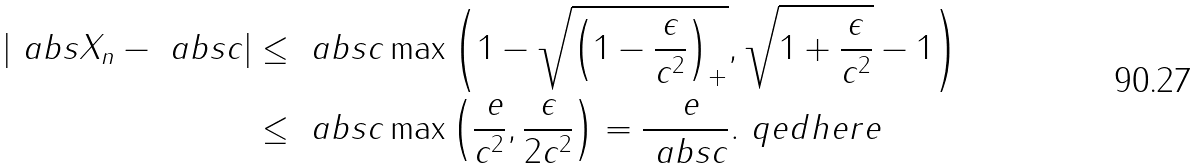Convert formula to latex. <formula><loc_0><loc_0><loc_500><loc_500>\left | \ a b s { X _ { n } } - \ a b s { c } \right | & \leq \ a b s { c } \max \left ( 1 - \sqrt { \left ( 1 - \frac { \epsilon } { c ^ { 2 } } \right ) _ { + } } , \sqrt { 1 + \frac { \epsilon } { c ^ { 2 } } } - 1 \right ) \\ & \leq \ a b s { c } \max \left ( \frac { \ e } { c ^ { 2 } } , \frac { \epsilon } { 2 c ^ { 2 } } \right ) = \frac { \ e } { \ a b s { c } } . \ q e d h e r e</formula> 